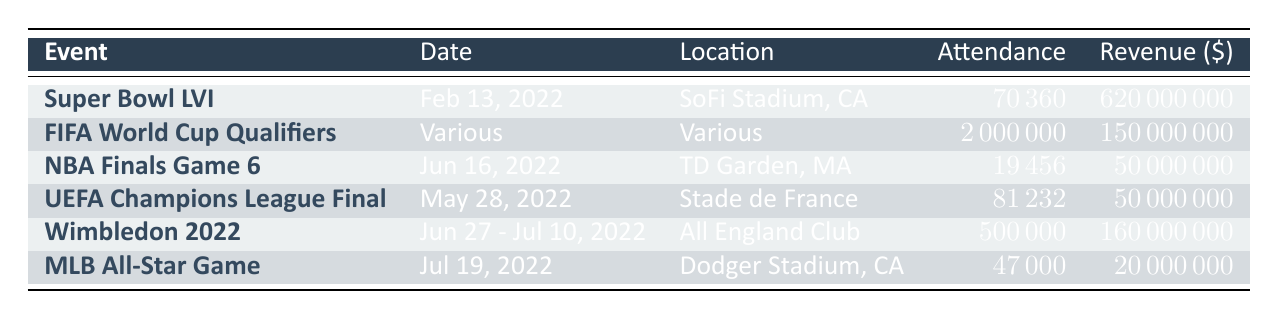What is the attendance for the Super Bowl LVI? The table lists the attendance for the Super Bowl LVI as 70360.
Answer: 70360 How much revenue did Wimbledon 2022 generate? From the table, the revenue for Wimbledon 2022 is stated as 160000000.
Answer: 160000000 Which event had the highest attendance in 2022? The 2022 FIFA World Cup Qualifiers had the highest attendance at 2000000, compared to other events listed in the table.
Answer: 2000000 What is the total attendance across all the events listed in the table? We sum the attendance of each event: 70360 + 2000000 + 19456 + 81232 + 500000 + 47000 = 2761048.
Answer: 2761048 Did the NBA Finals Game 6 generate more revenue than the UEFA Champions League Final? The NBA Finals Game 6 had a revenue of 50000000, which is equal to the revenue of the UEFA Champions League Final, so the answer is no.
Answer: No Which event took place in the month of July? The table indicates that the only event in July is the MLB All-Star Game, which took place on July 19, 2022.
Answer: MLB All-Star Game How much more revenue did the Super Bowl LVI generate compared to the NBA Finals Game 6? The revenue for the Super Bowl LVI is 620000000, and for the NBA Finals Game 6, it is 50000000. The difference is 620000000 - 50000000 = 570000000.
Answer: 570000000 Is the attendance at the UEFA Champions League Final greater than the attendance at the NBA Finals Game 6? The attendance for the UEFA Champions League Final is 81232, while the NBA Finals Game 6 had an attendance of 19456. Since 81232 is greater than 19456, the answer is yes.
Answer: Yes What is the average attendance for the events listed? To find the average, sum the attendances: 2761048 and divide by the number of events (6). Average = 2761048 / 6 ≈ 460174.67.
Answer: 460174.67 